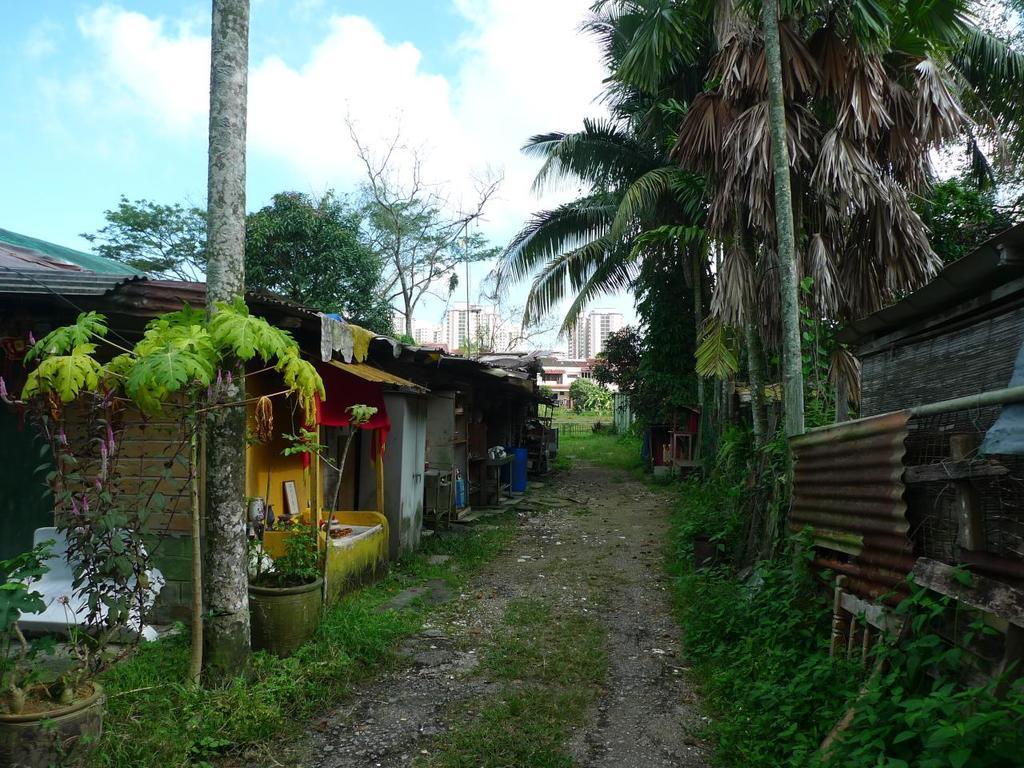Describe this image in one or two sentences. In this image I can see a walkway in the center. There are tin sheets and trees on the right. There is a plant, tree trunk and houses on the left. There are trees and buildings at the back. 